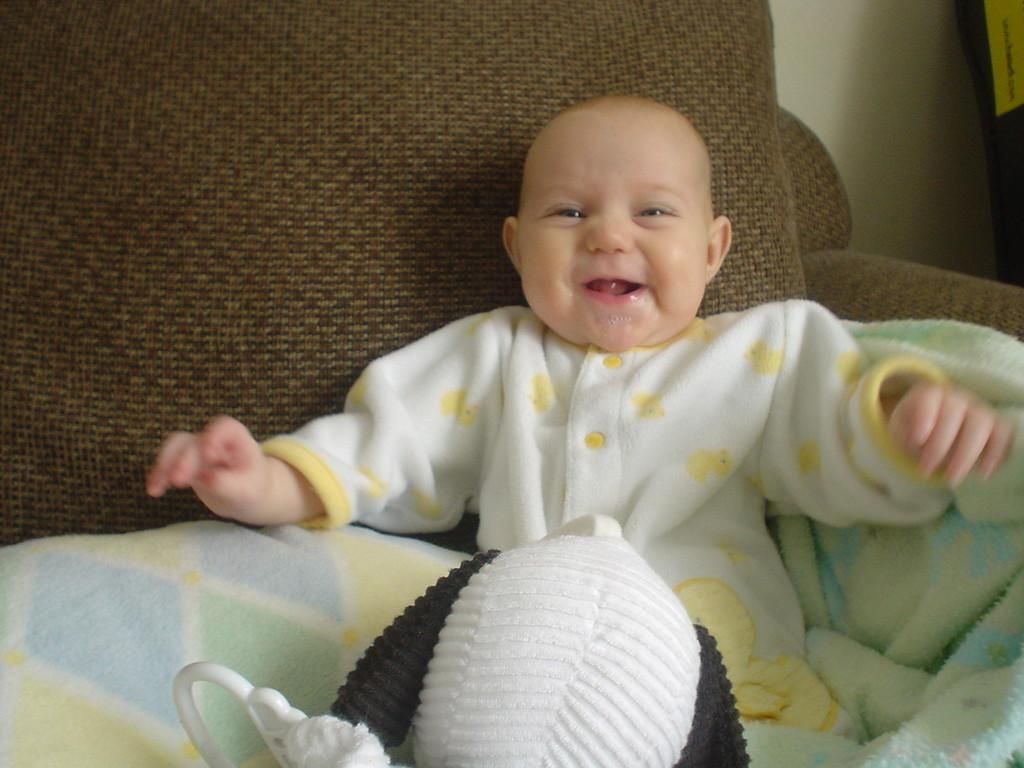What is the main subject of the image? There is a baby in the image. Where is the baby located? The baby is sitting on a sofa. What is the baby wearing? The baby is wearing a white dress. What color is the sofa? The sofa is brown in color. What can be seen in the background of the image? There is a wall in the background of the image. Can you tell me how many rifles are visible in the image? There are no rifles present in the image. What is the rate of the baby's breathing in the image? The image does not provide information about the baby's breathing rate. 